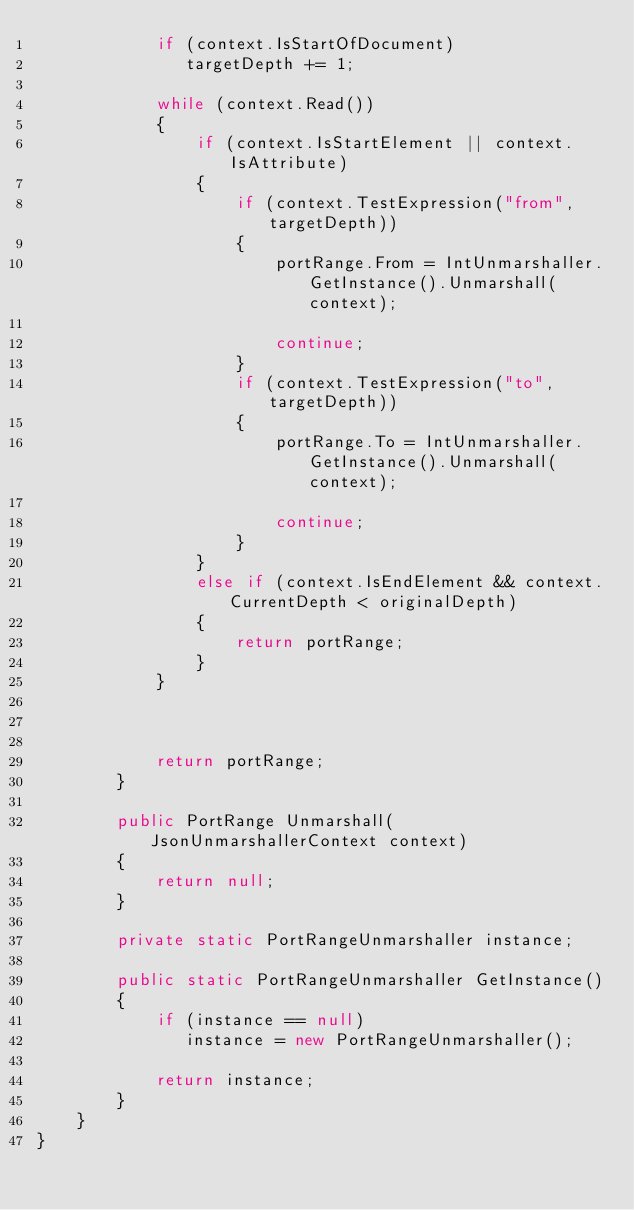Convert code to text. <code><loc_0><loc_0><loc_500><loc_500><_C#_>            if (context.IsStartOfDocument) 
               targetDepth += 1;
            
            while (context.Read())
            {
                if (context.IsStartElement || context.IsAttribute)
                {
                    if (context.TestExpression("from", targetDepth))
                    {
                        portRange.From = IntUnmarshaller.GetInstance().Unmarshall(context);
                            
                        continue;
                    }
                    if (context.TestExpression("to", targetDepth))
                    {
                        portRange.To = IntUnmarshaller.GetInstance().Unmarshall(context);
                            
                        continue;
                    }
                }
                else if (context.IsEndElement && context.CurrentDepth < originalDepth)
                {
                    return portRange;
                }
            }
                        


            return portRange;
        }

        public PortRange Unmarshall(JsonUnmarshallerContext context) 
        {
            return null;
        }

        private static PortRangeUnmarshaller instance;

        public static PortRangeUnmarshaller GetInstance() 
        {
            if (instance == null) 
               instance = new PortRangeUnmarshaller();

            return instance;
        }
    }
}
    
</code> 